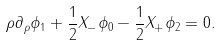Convert formula to latex. <formula><loc_0><loc_0><loc_500><loc_500>\rho \partial _ { \rho } \phi _ { 1 } + \frac { 1 } { 2 } X _ { - } \phi _ { 0 } - \frac { 1 } { 2 } X _ { + } \phi _ { 2 } = 0 .</formula> 